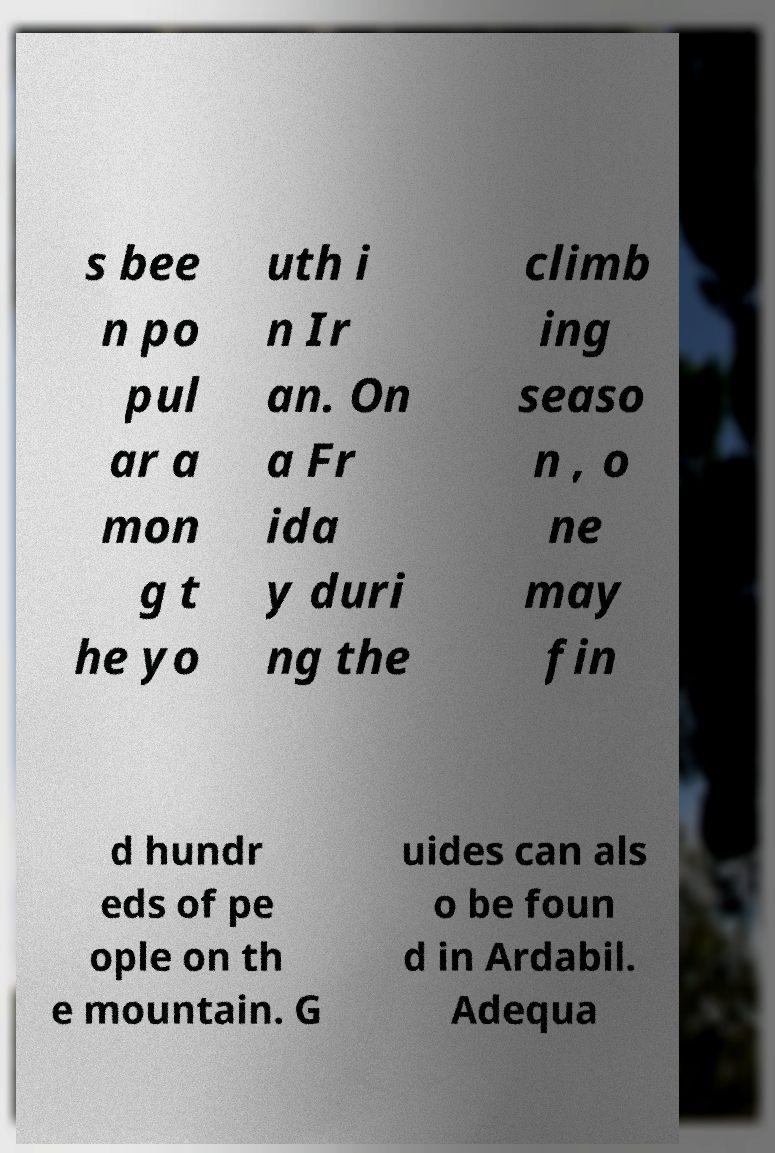There's text embedded in this image that I need extracted. Can you transcribe it verbatim? s bee n po pul ar a mon g t he yo uth i n Ir an. On a Fr ida y duri ng the climb ing seaso n , o ne may fin d hundr eds of pe ople on th e mountain. G uides can als o be foun d in Ardabil. Adequa 